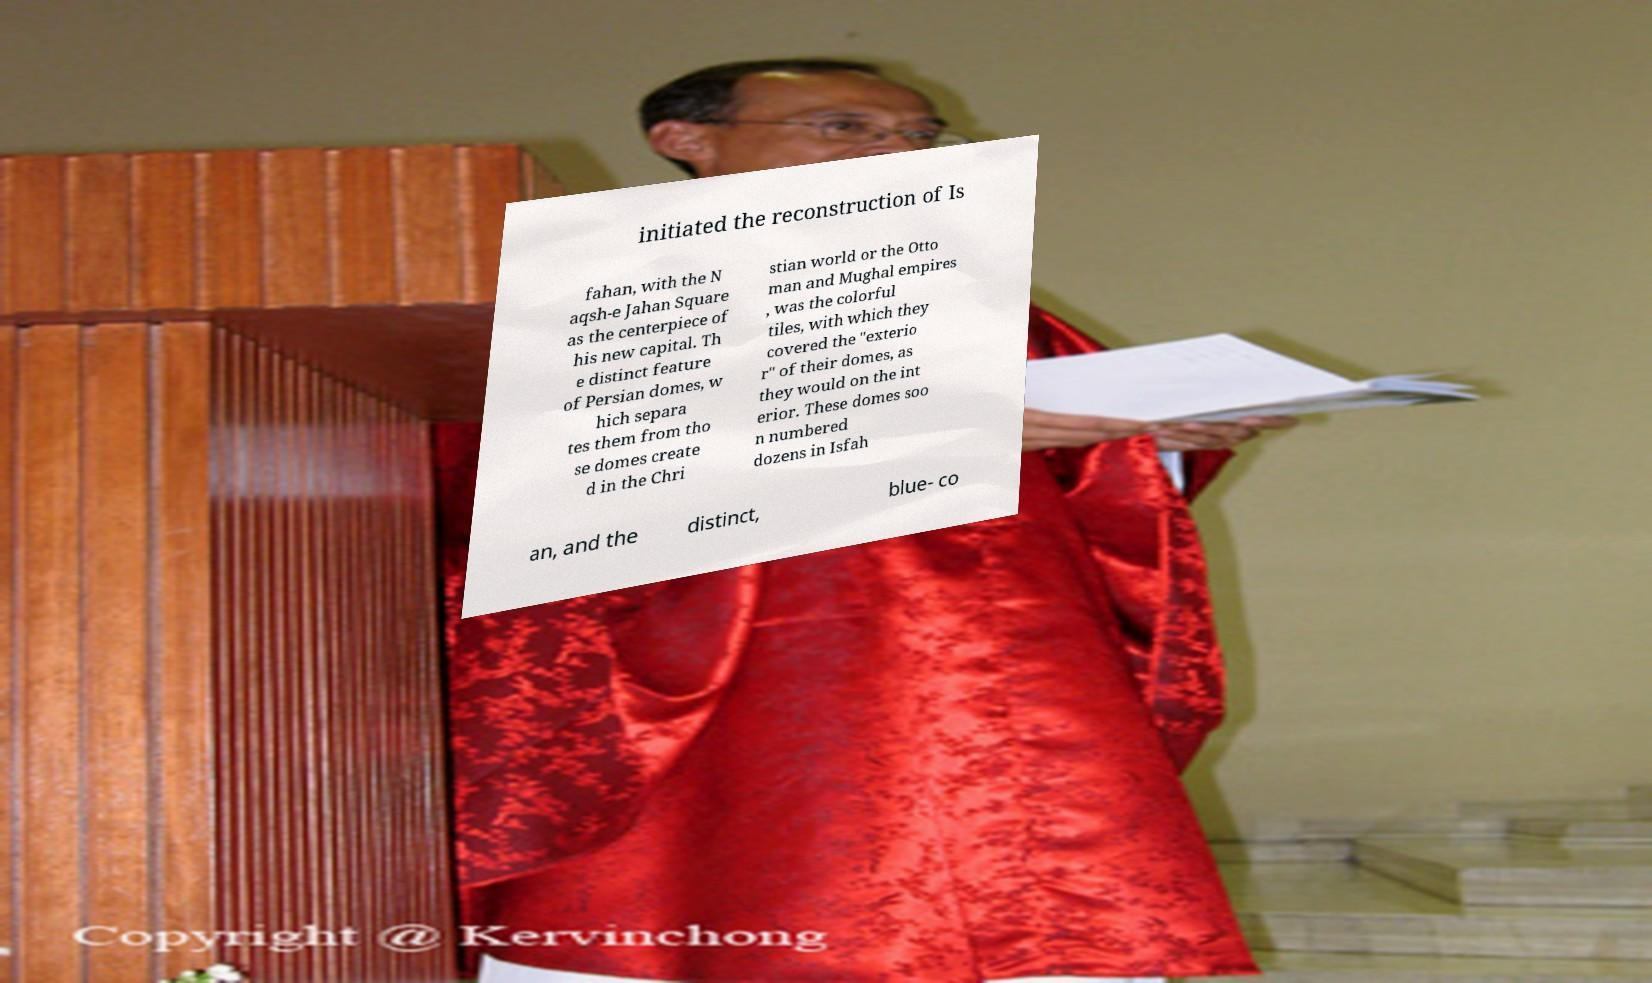Can you read and provide the text displayed in the image?This photo seems to have some interesting text. Can you extract and type it out for me? initiated the reconstruction of Is fahan, with the N aqsh-e Jahan Square as the centerpiece of his new capital. Th e distinct feature of Persian domes, w hich separa tes them from tho se domes create d in the Chri stian world or the Otto man and Mughal empires , was the colorful tiles, with which they covered the "exterio r" of their domes, as they would on the int erior. These domes soo n numbered dozens in Isfah an, and the distinct, blue- co 